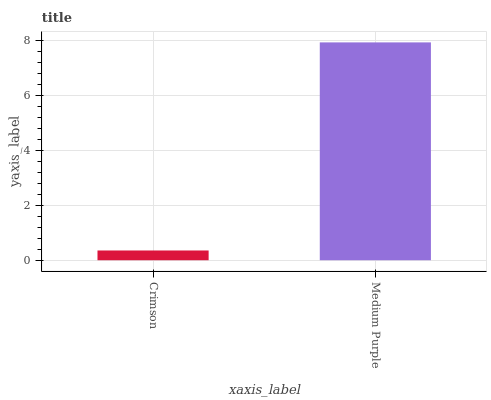Is Crimson the minimum?
Answer yes or no. Yes. Is Medium Purple the maximum?
Answer yes or no. Yes. Is Medium Purple the minimum?
Answer yes or no. No. Is Medium Purple greater than Crimson?
Answer yes or no. Yes. Is Crimson less than Medium Purple?
Answer yes or no. Yes. Is Crimson greater than Medium Purple?
Answer yes or no. No. Is Medium Purple less than Crimson?
Answer yes or no. No. Is Medium Purple the high median?
Answer yes or no. Yes. Is Crimson the low median?
Answer yes or no. Yes. Is Crimson the high median?
Answer yes or no. No. Is Medium Purple the low median?
Answer yes or no. No. 